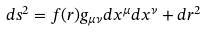<formula> <loc_0><loc_0><loc_500><loc_500>d s ^ { 2 } = f ( r ) g _ { \mu \nu } d x ^ { \mu } d x ^ { \nu } + d r ^ { 2 }</formula> 